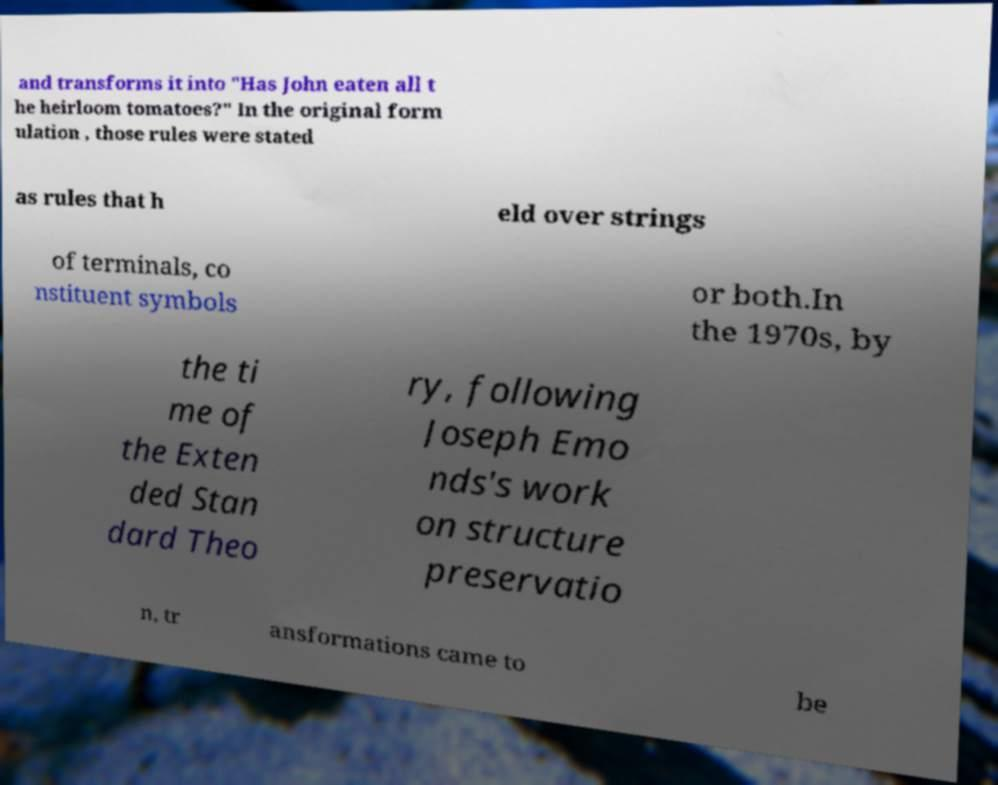Can you read and provide the text displayed in the image?This photo seems to have some interesting text. Can you extract and type it out for me? and transforms it into "Has John eaten all t he heirloom tomatoes?" In the original form ulation , those rules were stated as rules that h eld over strings of terminals, co nstituent symbols or both.In the 1970s, by the ti me of the Exten ded Stan dard Theo ry, following Joseph Emo nds's work on structure preservatio n, tr ansformations came to be 